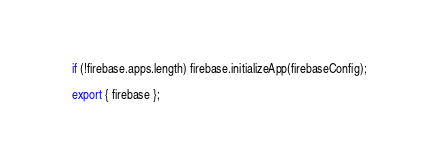<code> <loc_0><loc_0><loc_500><loc_500><_JavaScript_>
if (!firebase.apps.length) firebase.initializeApp(firebaseConfig);

export { firebase };</code> 